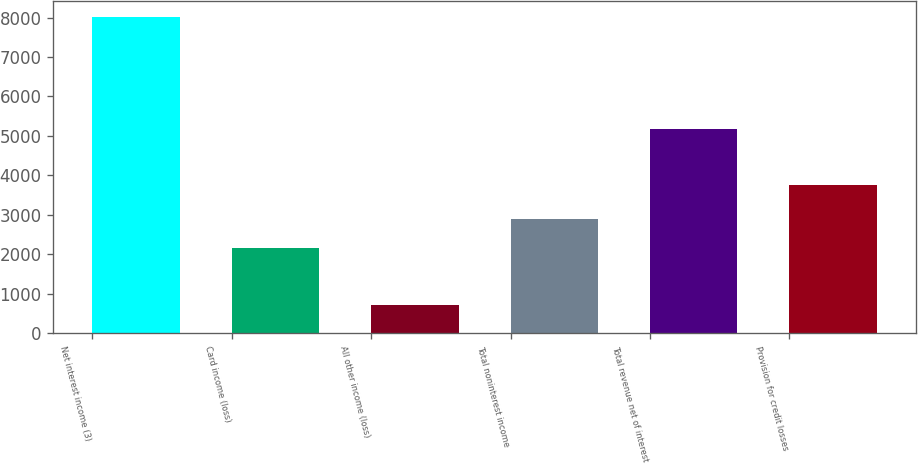Convert chart. <chart><loc_0><loc_0><loc_500><loc_500><bar_chart><fcel>Net interest income (3)<fcel>Card income (loss)<fcel>All other income (loss)<fcel>Total noninterest income<fcel>Total revenue net of interest<fcel>Provision for credit losses<nl><fcel>8019<fcel>2164<fcel>711<fcel>2894.8<fcel>5168<fcel>3769<nl></chart> 